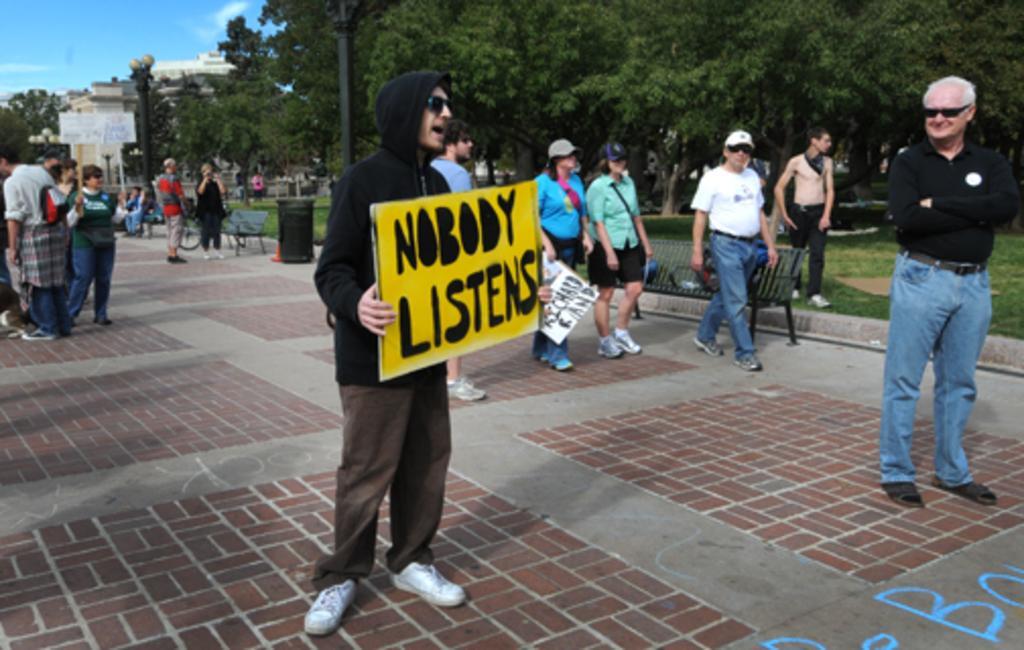Please provide a concise description of this image. In this picture we can see a person holding a board in his hands. There are a few people on the path. There are some benches, dustbin, poles,street lights,trees and a building in the background. We can see a person holding a whiteboard at the back. Some grass is visible on the ground. Sky is blue in color. We can see some clouds in the sky. 